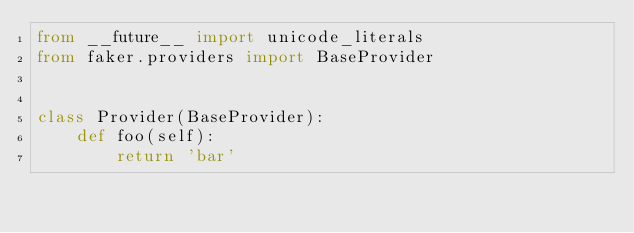Convert code to text. <code><loc_0><loc_0><loc_500><loc_500><_Python_>from __future__ import unicode_literals
from faker.providers import BaseProvider


class Provider(BaseProvider):
    def foo(self):
        return 'bar'
</code> 